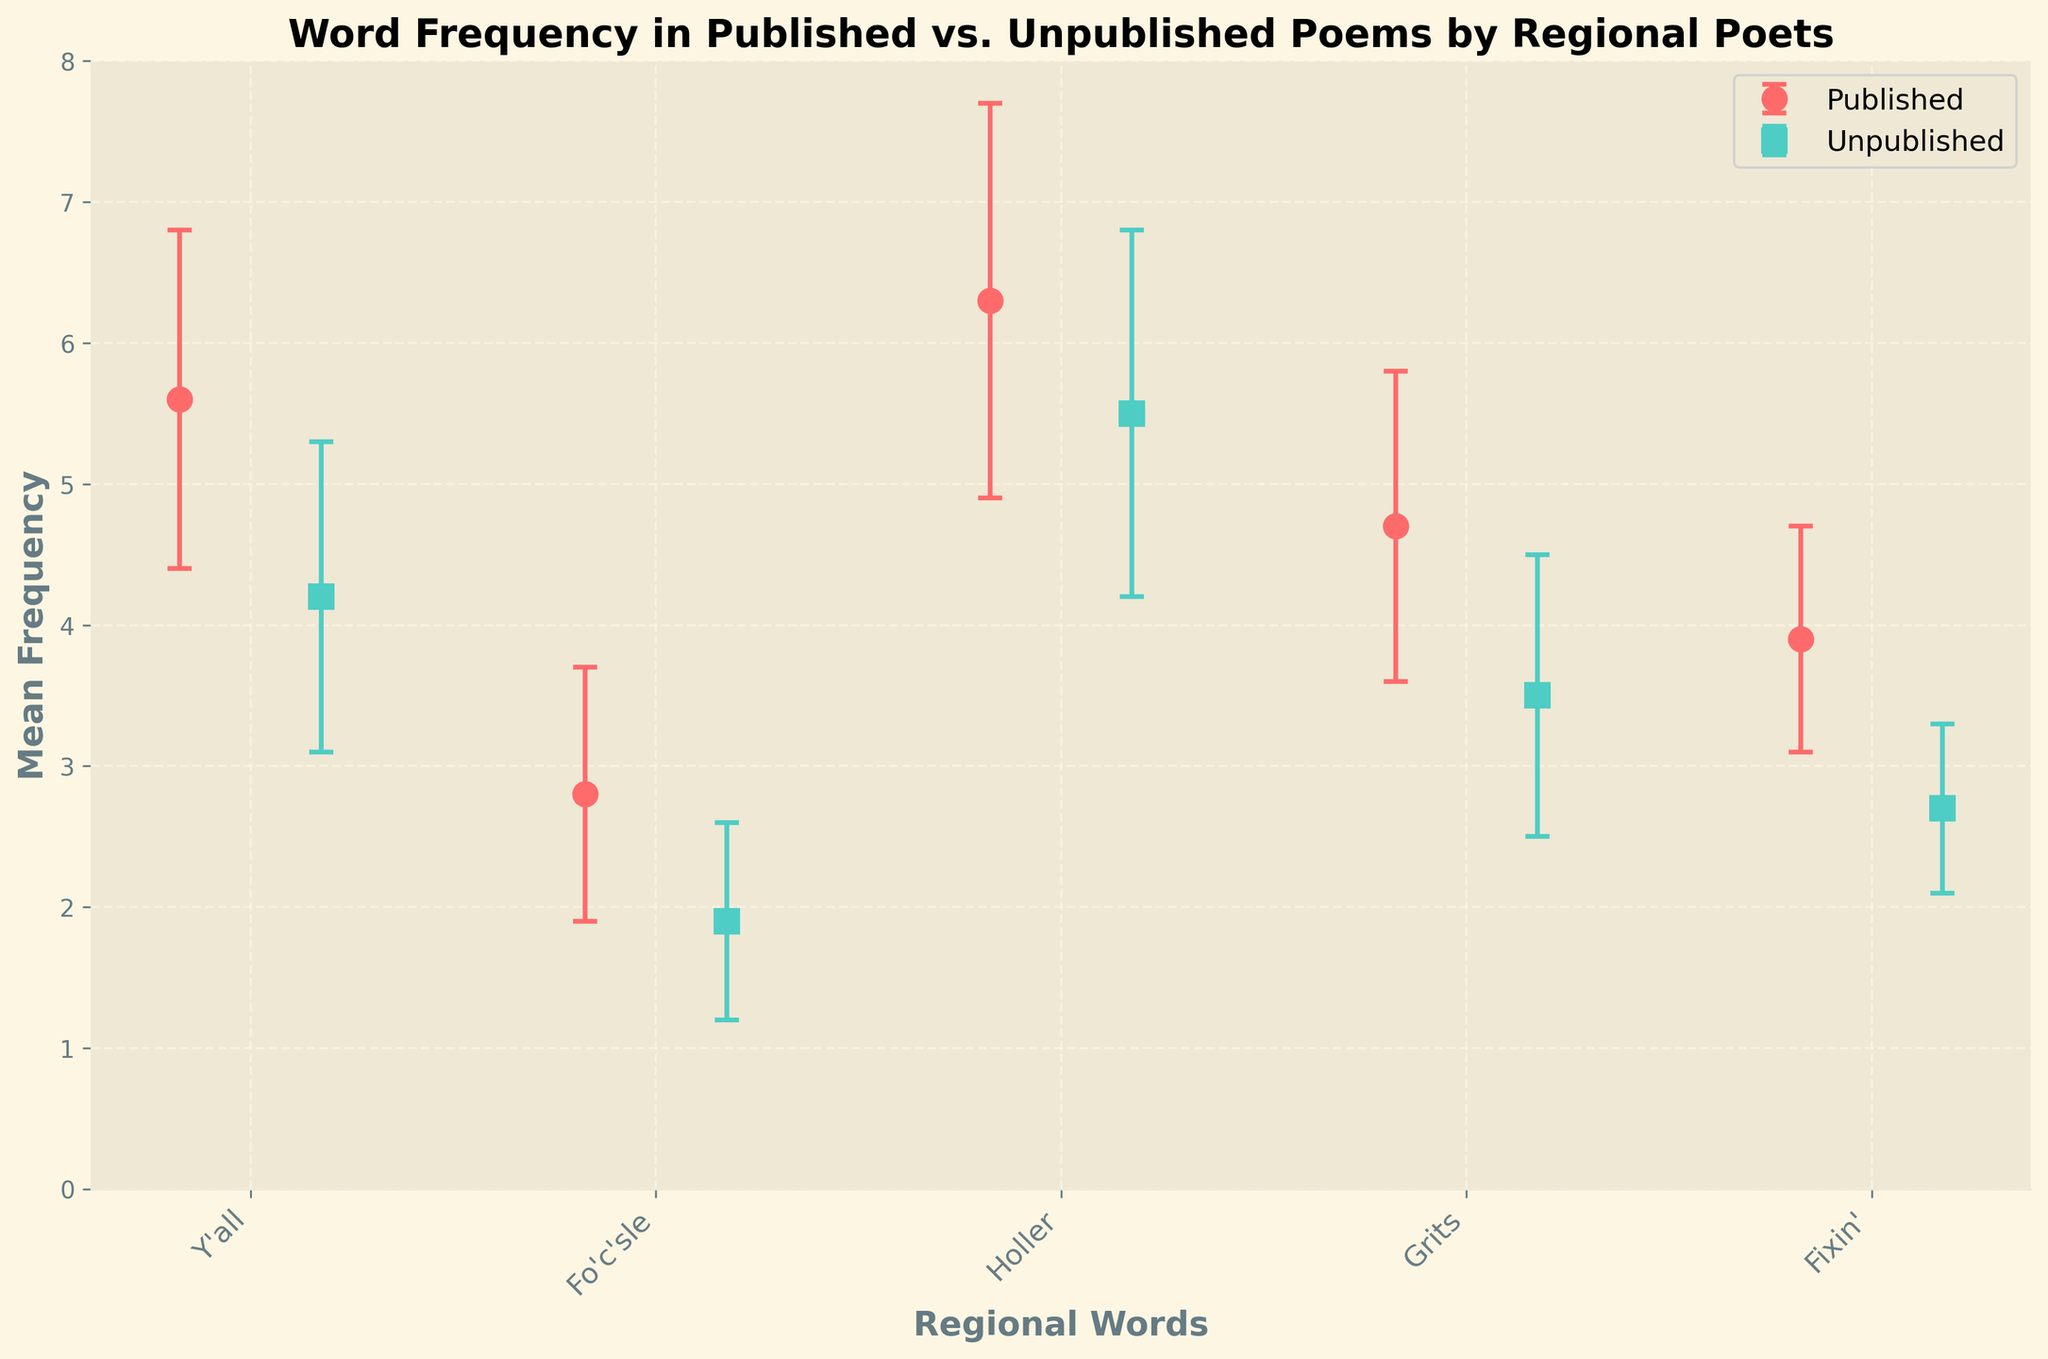What's the title of the figure? The title typically appears at the top of the figure and provides an overarching description of the content. Just read the text at the top.
Answer: Word Frequency in Published vs. Unpublished Poems by Regional Poets What's the color representation for published poems? Colors help distinguish different groups in the plot. To find the color associated with published poems, look for the label 'Published' next to the corresponding color in the legend.
Answer: Red Which word has the highest mean frequency in published poems? To identify the word with the highest mean frequency in published poems, look at the topmost point within the red data series.
Answer: Holler Which word has the highest mean frequency in unpublished poems? Similar to the previous question, look at the topmost point within the green data series for the unpublished poems.
Answer: Holler What's the mean frequency of the word 'Y'all' in unpublished poems? Locate the data point corresponding to 'Y'all' in the green series, and read its value on the y-axis.
Answer: 4.2 How does the mean frequency of 'Fo'c'sle' compare between published and unpublished poems? Compare the height of the points corresponding to 'Fo'c'sle' in both red and green series. Read the y-values for both data points and indicate which is higher.
Answer: Higher in published What's the difference in the mean frequency of 'Grits' between published and unpublished poems? To find the difference, subtract the mean frequency of 'Grits' in unpublished poems from that in published poems.
Answer: 1.2 (4.7 - 3.5) Which word shows the largest error bar for published poems? The largest error bar corresponds to the longest vertical line extending from a data point in the red series.
Answer: Holler Which word has the smallest standard deviation in unpublished poems? The smallest error bar corresponds to the shortest vertical line extending from a data point in the green series.
Answer: Fixin' How do the standard deviations of 'Holler' compare between published and unpublished poems? Compare the lengths of the error bars for 'Holler' in both the red and green series to determine which is larger or if they are the same.
Answer: Larger in published 